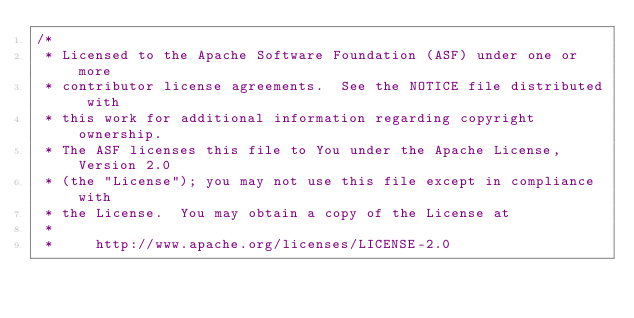<code> <loc_0><loc_0><loc_500><loc_500><_Java_>/*
 * Licensed to the Apache Software Foundation (ASF) under one or more
 * contributor license agreements.  See the NOTICE file distributed with
 * this work for additional information regarding copyright ownership.
 * The ASF licenses this file to You under the Apache License, Version 2.0
 * (the "License"); you may not use this file except in compliance with
 * the License.  You may obtain a copy of the License at
 *
 *     http://www.apache.org/licenses/LICENSE-2.0</code> 